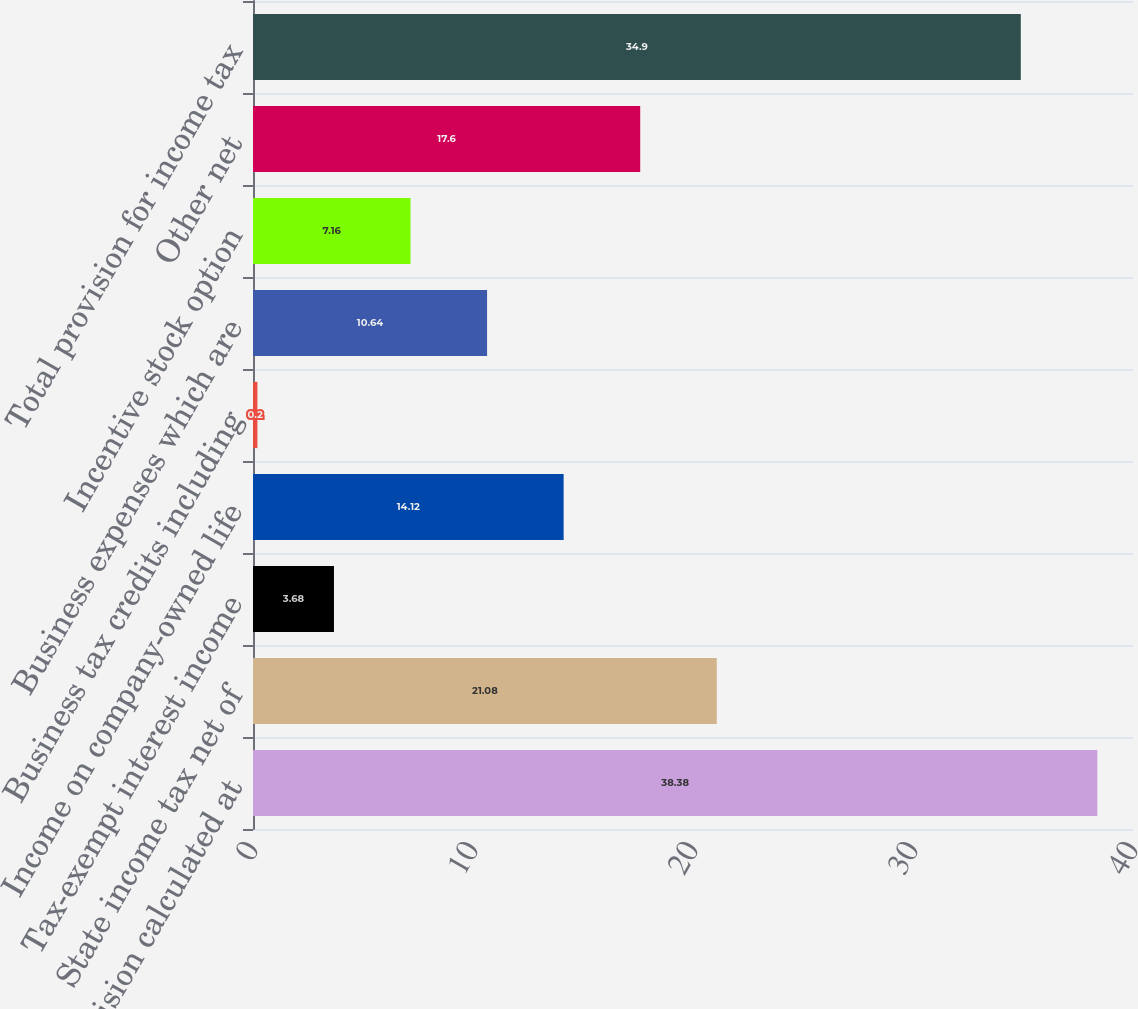<chart> <loc_0><loc_0><loc_500><loc_500><bar_chart><fcel>Provision calculated at<fcel>State income tax net of<fcel>Tax-exempt interest income<fcel>Income on company-owned life<fcel>Business tax credits including<fcel>Business expenses which are<fcel>Incentive stock option<fcel>Other net<fcel>Total provision for income tax<nl><fcel>38.38<fcel>21.08<fcel>3.68<fcel>14.12<fcel>0.2<fcel>10.64<fcel>7.16<fcel>17.6<fcel>34.9<nl></chart> 